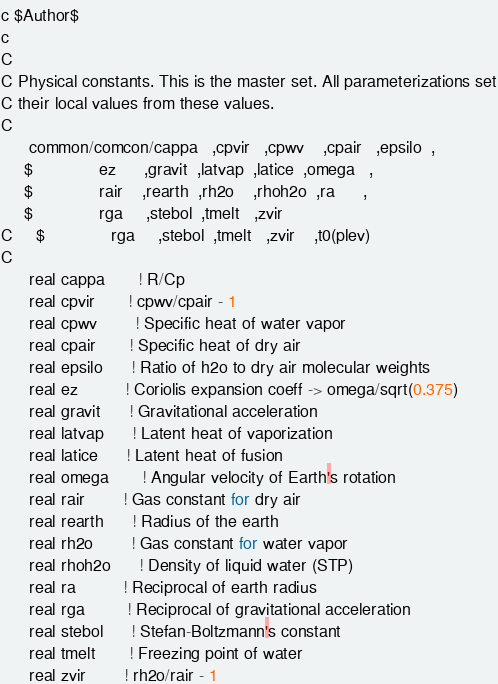<code> <loc_0><loc_0><loc_500><loc_500><_C_>c $Author$
c
C
C Physical constants. This is the master set. All parameterizations set
C their local values from these values.
C
      common/comcon/cappa   ,cpvir   ,cpwv    ,cpair   ,epsilo  ,
     $              ez      ,gravit  ,latvap  ,latice  ,omega   ,
     $              rair    ,rearth  ,rh2o    ,rhoh2o  ,ra      ,
     $              rga     ,stebol  ,tmelt   ,zvir    
C     $              rga     ,stebol  ,tmelt   ,zvir    ,t0(plev)
C
      real cappa       ! R/Cp
      real cpvir       ! cpwv/cpair - 1
      real cpwv        ! Specific heat of water vapor
      real cpair       ! Specific heat of dry air
      real epsilo      ! Ratio of h2o to dry air molecular weights 
      real ez          ! Coriolis expansion coeff -> omega/sqrt(0.375)
      real gravit      ! Gravitational acceleration
      real latvap      ! Latent heat of vaporization
      real latice      ! Latent heat of fusion
      real omega       ! Angular velocity of Earth's rotation
      real rair        ! Gas constant for dry air
      real rearth      ! Radius of the earth
      real rh2o        ! Gas constant for water vapor
      real rhoh2o      ! Density of liquid water (STP)
      real ra          ! Reciprocal of earth radius
      real rga         ! Reciprocal of gravitational acceleration
      real stebol      ! Stefan-Boltzmann's constant
      real tmelt       ! Freezing point of water
      real zvir        ! rh2o/rair - 1</code> 